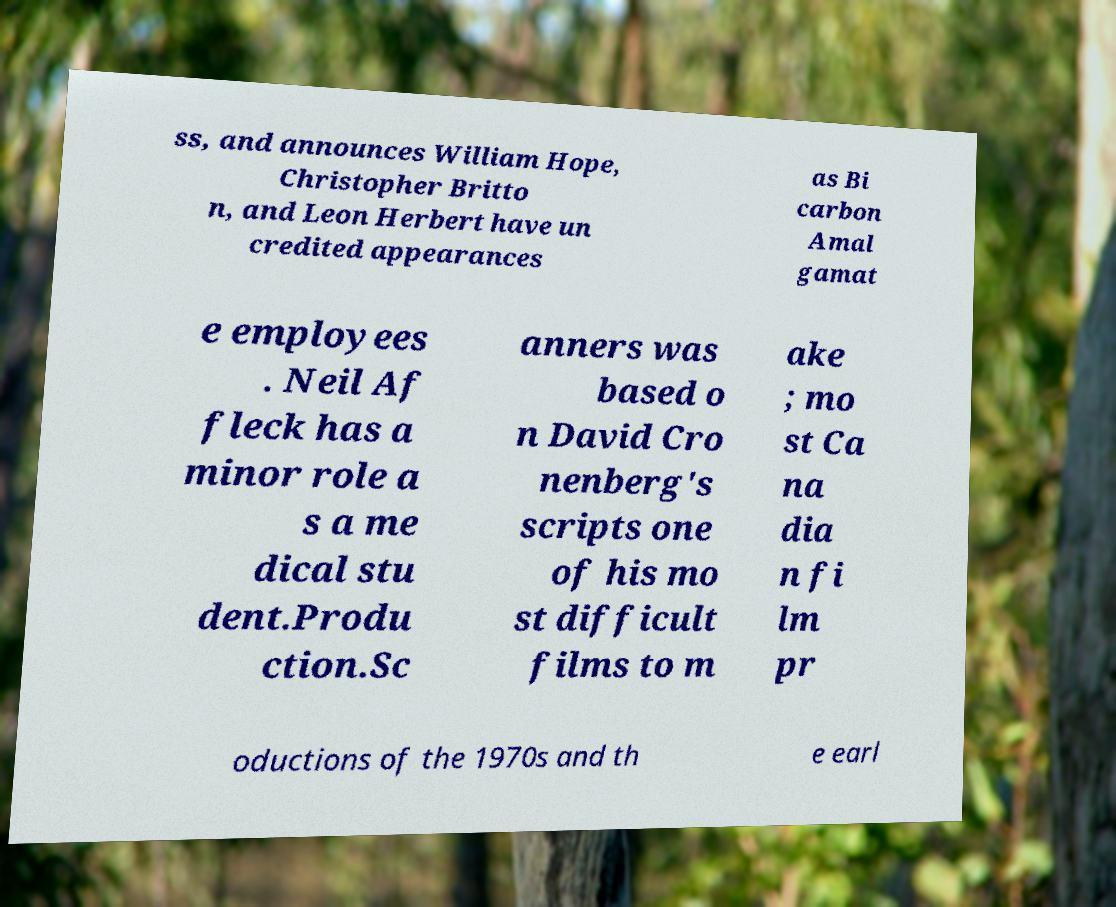Could you assist in decoding the text presented in this image and type it out clearly? ss, and announces William Hope, Christopher Britto n, and Leon Herbert have un credited appearances as Bi carbon Amal gamat e employees . Neil Af fleck has a minor role a s a me dical stu dent.Produ ction.Sc anners was based o n David Cro nenberg's scripts one of his mo st difficult films to m ake ; mo st Ca na dia n fi lm pr oductions of the 1970s and th e earl 